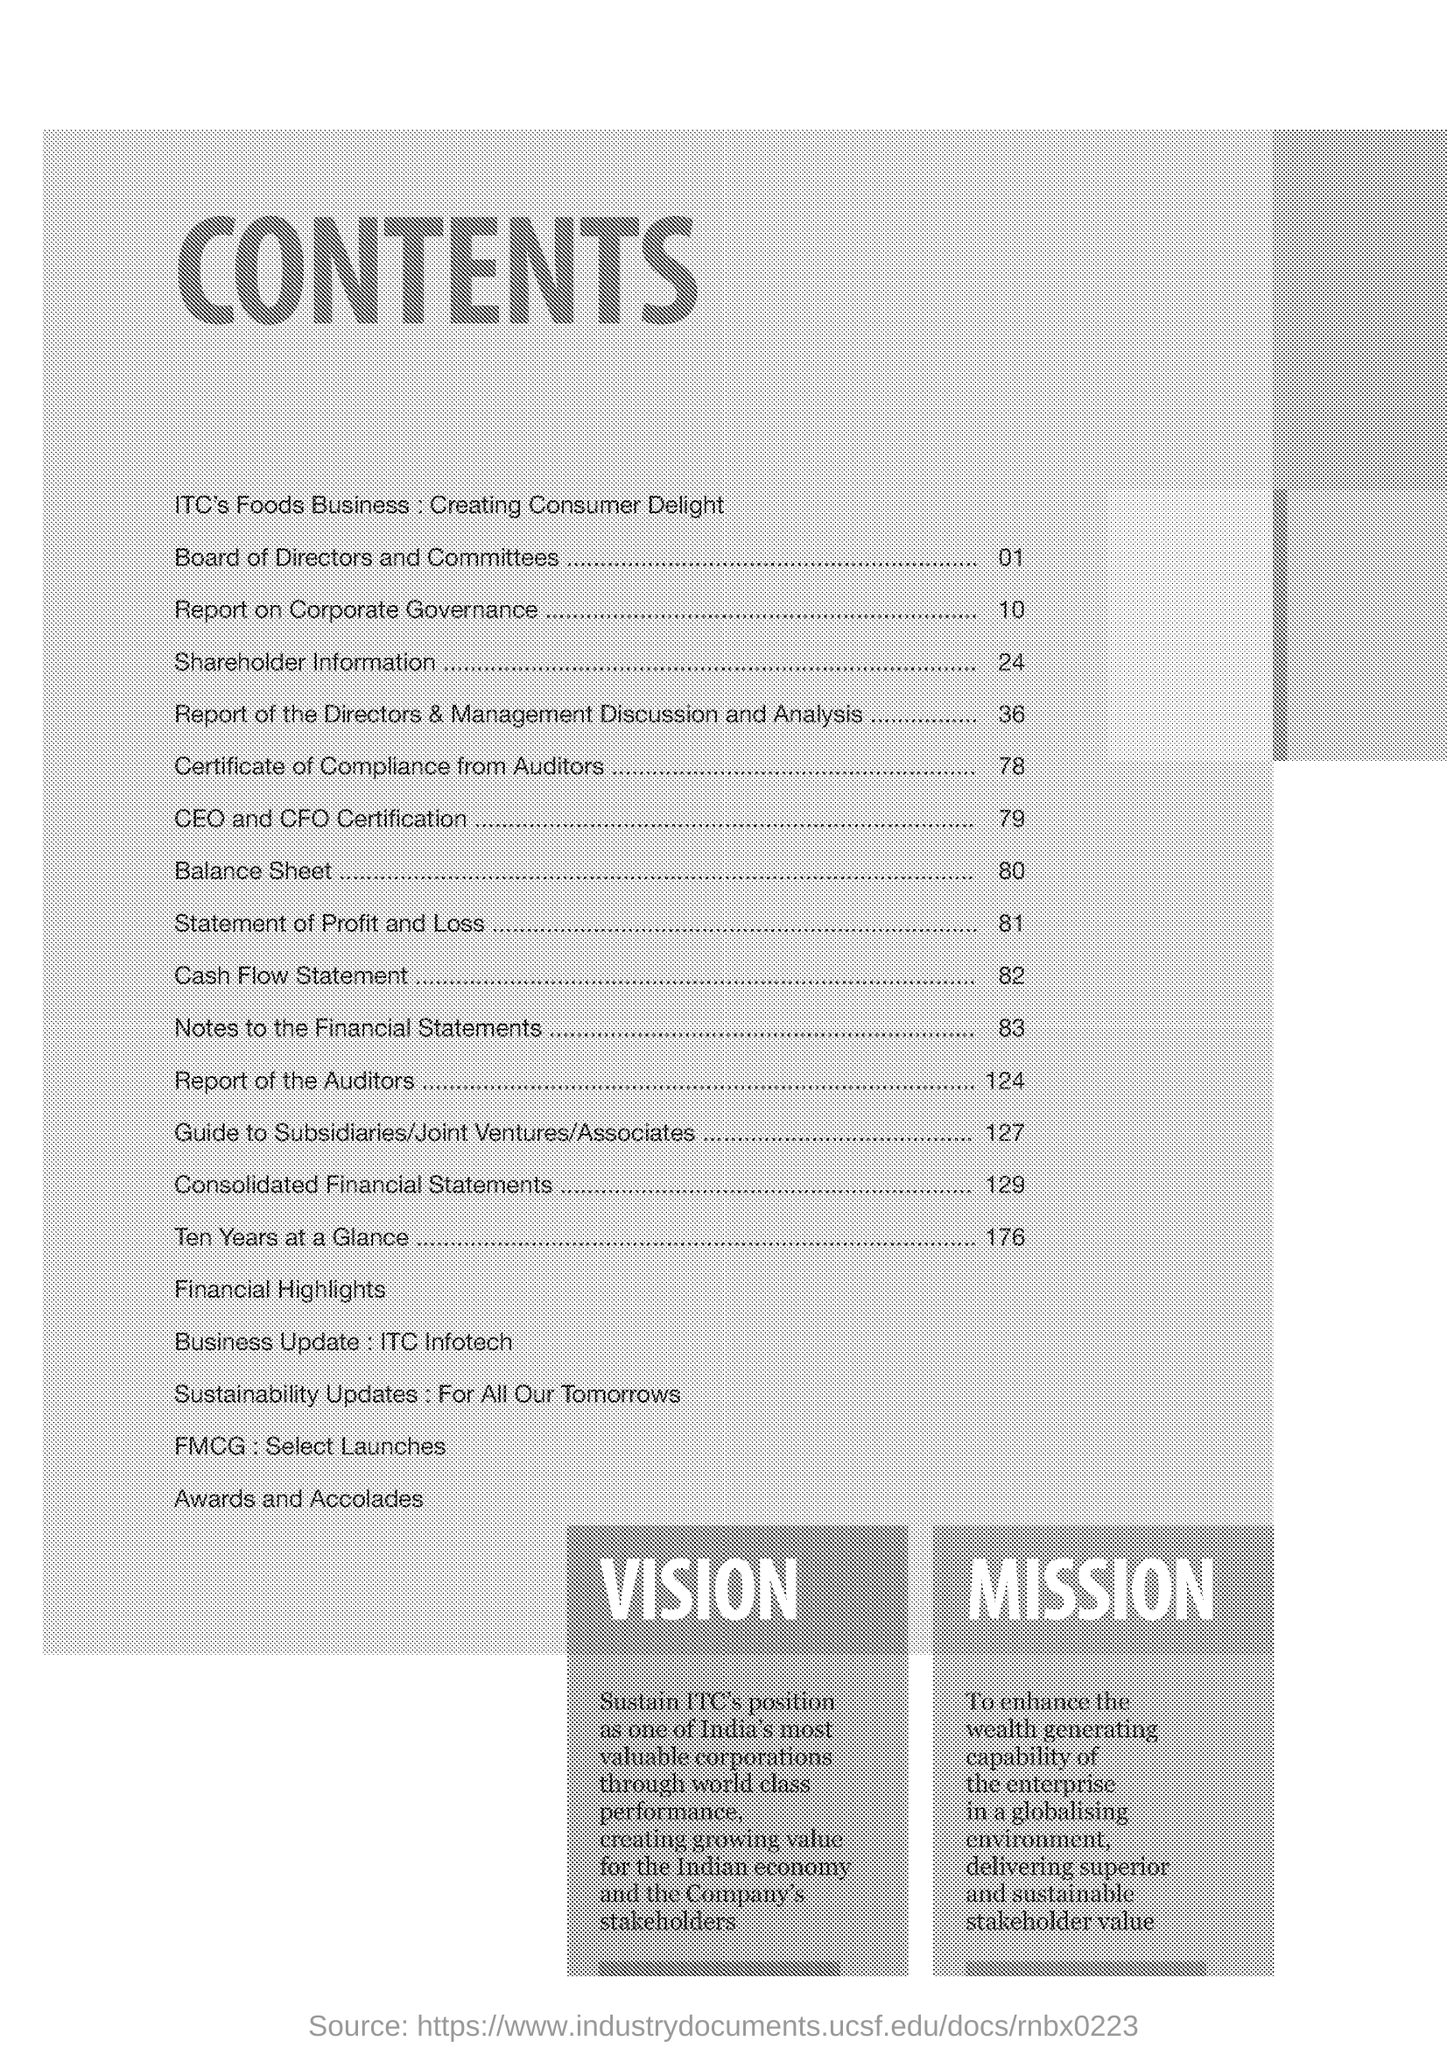Indicate a few pertinent items in this graphic. The balance sheet can be found on page 80. The page number for Shareholder Information is 24. The title of the document is [insert title]. 